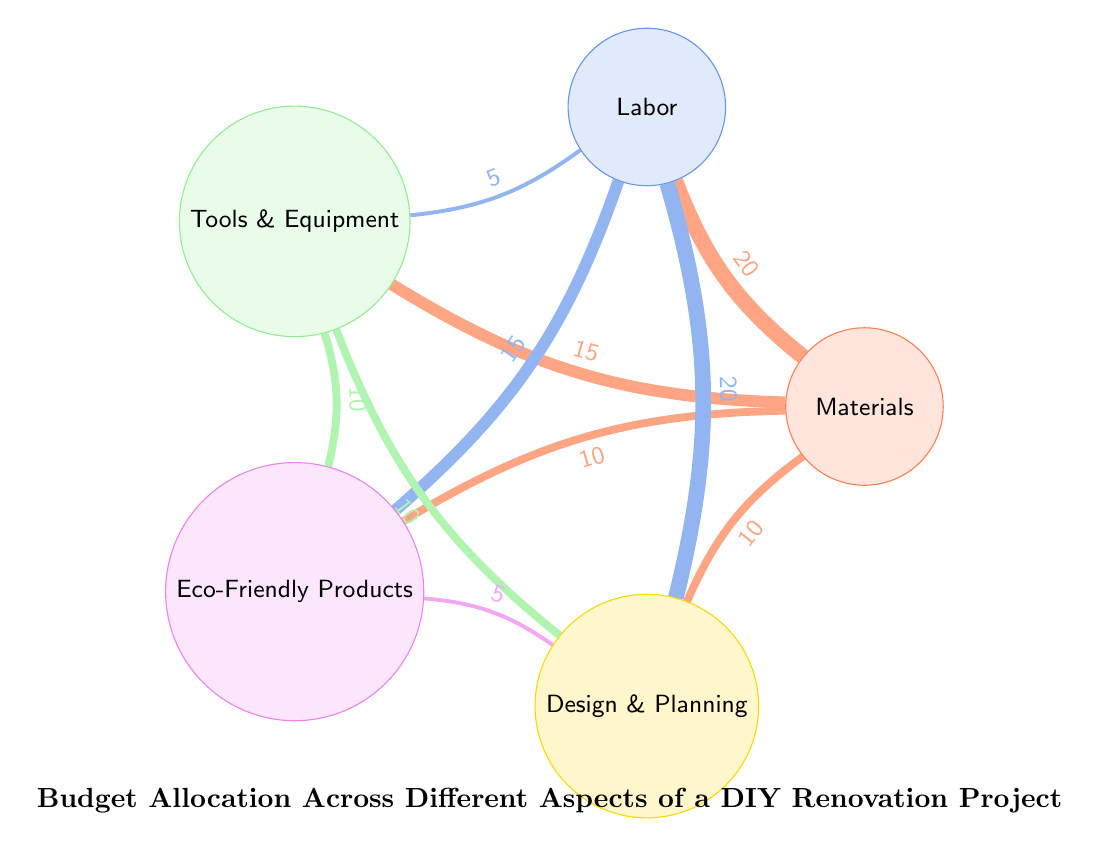What is the total number of nodes in the diagram? The nodes in the diagram represent different budget aspects. Counting the nodes listed, there are five named aspects: Materials, Labor, Tools & Equipment, Eco-Friendly Products, and Design & Planning.
Answer: 5 What is the value of the link from Labor to Eco-Friendly Products? The link from Labor to Eco-Friendly Products shows a value of 15, indicating the amount of budget allocated in that relationship.
Answer: 15 Which aspect has the highest budget allocation directed to Design & Planning? The link from Labor to Design & Planning has a value of 20, which is the highest allocation towards Design & Planning compared to other aspects.
Answer: Labor What is the relationship value between Tools & Equipment and Eco-Friendly Products? The link between Tools & Equipment and Eco-Friendly Products displays a value of 10, indicating the budget allocated between these two aspects.
Answer: 10 How much budget is allocated to Materials overall as a source? The values from Materials to other aspects are 20 (Labor), 15 (Tools & Equipment), 10 (Eco-Friendly Products), and 10 (Design & Planning), totaling 55 when summed up.
Answer: 55 Which two aspects both have a direct link to Design & Planning? The aspects with direct links to Design & Planning are Labor (value 20) and Tools & Equipment (value 10). Both are connected directly to Design & Planning.
Answer: Labor and Tools & Equipment What is the diagram's flow from Eco-Friendly Products to Design & Planning? Eco-Friendly Products has a connection to Design & Planning with a link value of 5, showing a smaller budget allocation compared to other connections.
Answer: 5 Which node has the least outgoing links in the diagram? Analyzing the outgoing connections, Eco-Friendly Products has the fewest links (only to Design & Planning), making it the node with the least outgoing connections.
Answer: Eco-Friendly Products What is the total link value from Materials to all other aspects combined? The values of the outgoing links from Materials are 20 (Labor), 15 (Tools & Equipment), 10 (Eco-Friendly Products), and 10 (Design & Planning). Summing these gives a total of 55.
Answer: 55 